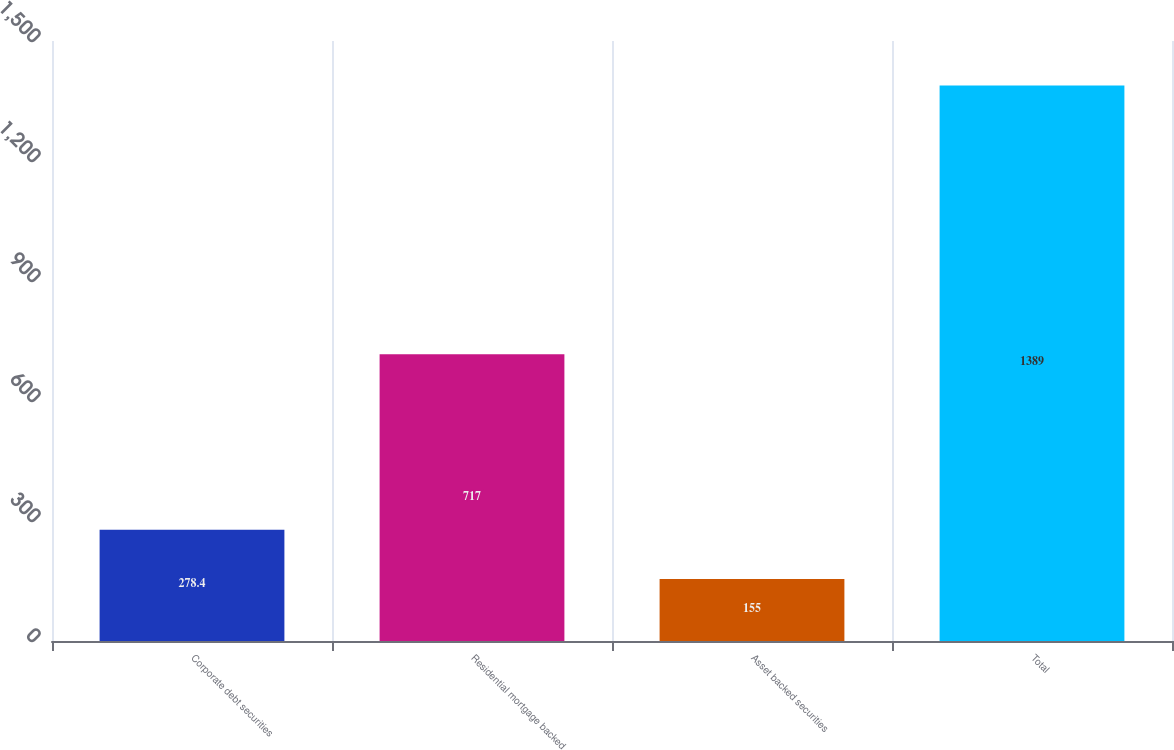Convert chart. <chart><loc_0><loc_0><loc_500><loc_500><bar_chart><fcel>Corporate debt securities<fcel>Residential mortgage backed<fcel>Asset backed securities<fcel>Total<nl><fcel>278.4<fcel>717<fcel>155<fcel>1389<nl></chart> 